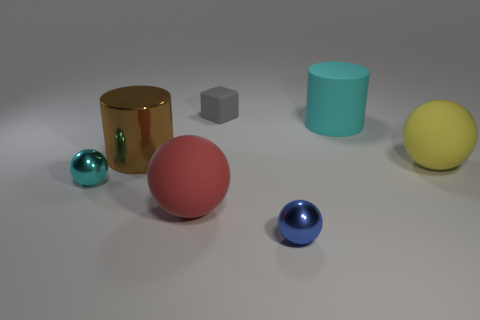Add 3 red matte balls. How many objects exist? 10 Subtract all cylinders. How many objects are left? 5 Subtract 0 cyan blocks. How many objects are left? 7 Subtract all blue balls. Subtract all blue spheres. How many objects are left? 5 Add 2 big cyan rubber things. How many big cyan rubber things are left? 3 Add 4 large yellow cylinders. How many large yellow cylinders exist? 4 